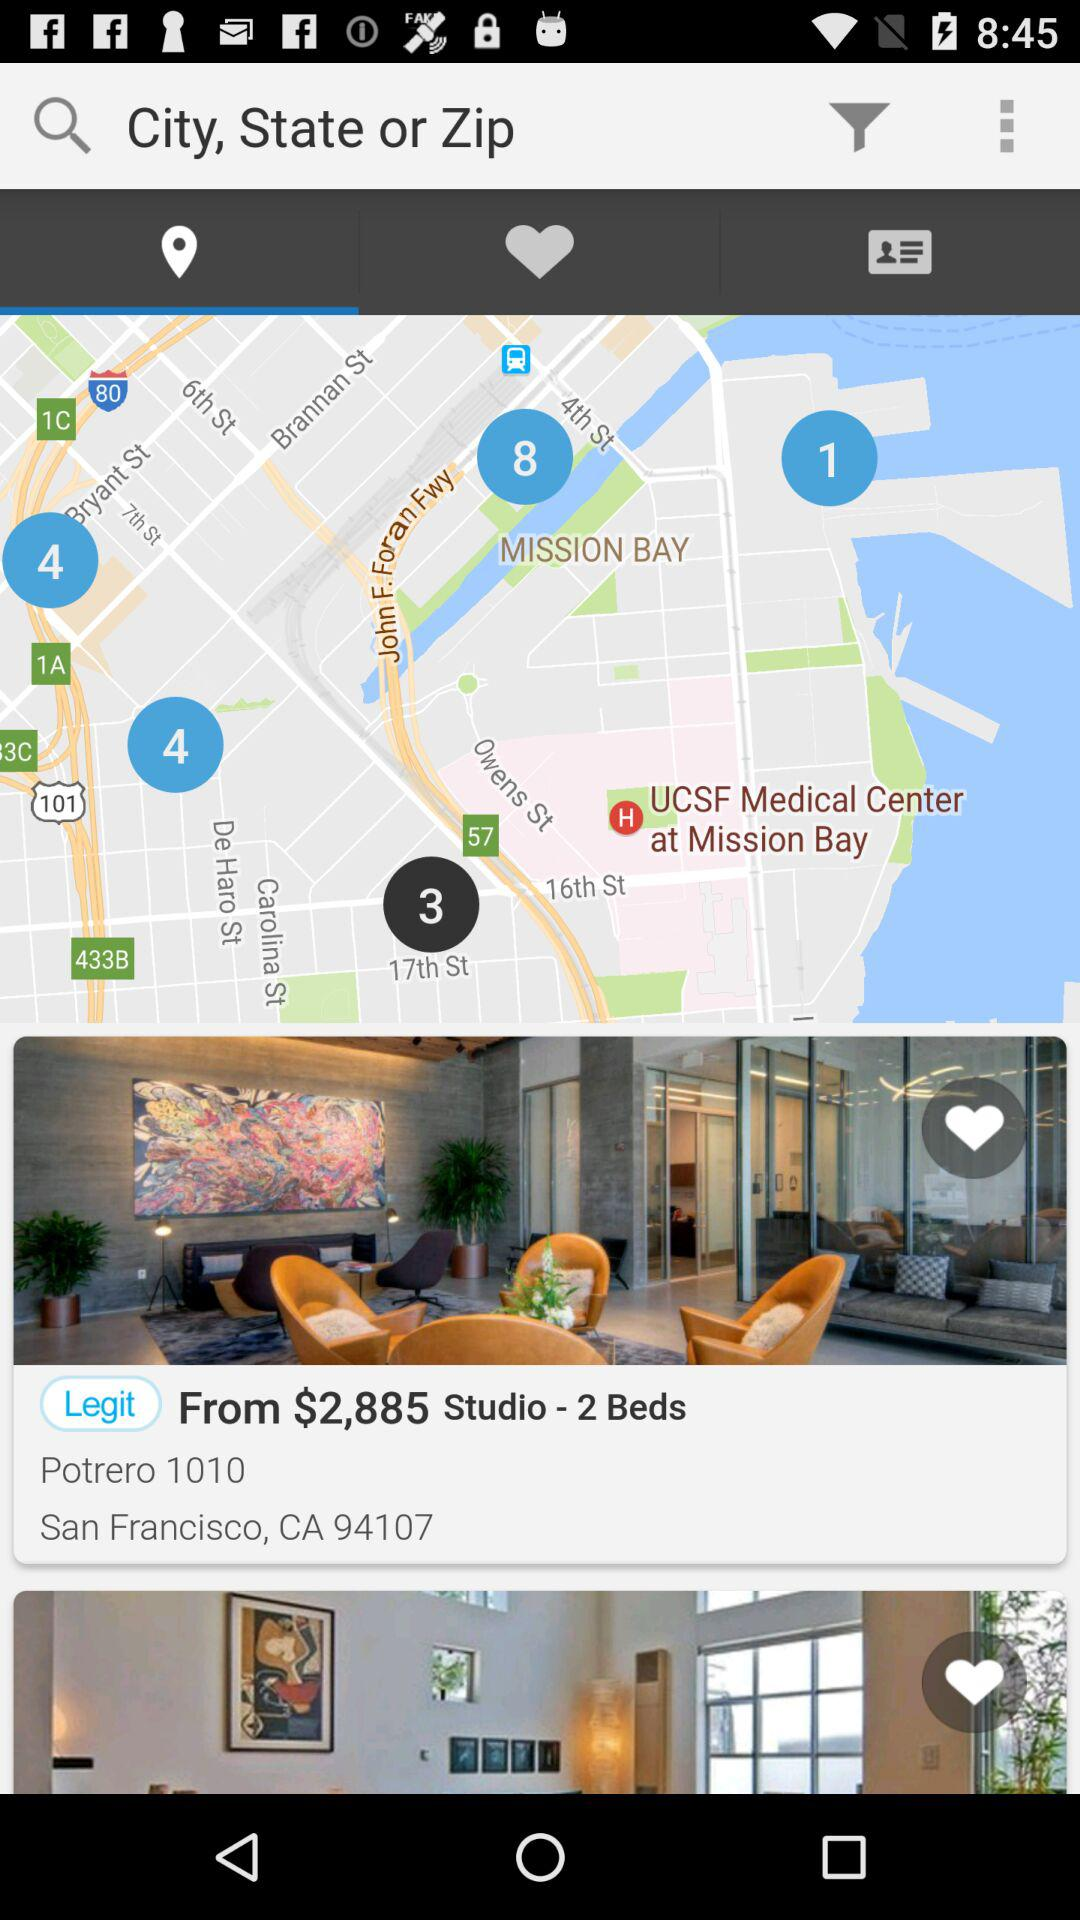What is the ZIP Code? The ZIP Code is 94107. 